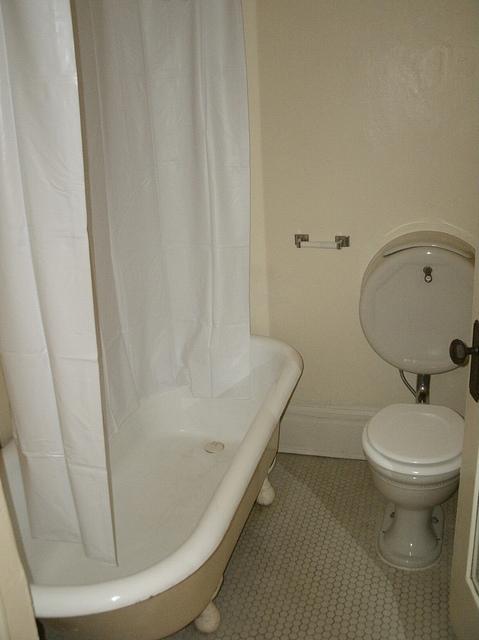Is there a bathtub in this bathroom?
Quick response, please. Yes. What is on the side of the tub?
Give a very brief answer. Toilet. Is the bathroom clean?
Quick response, please. Yes. Where is the bathroom floor?
Give a very brief answer. Bottom. Is the shower curtain on the outside of the tub?
Short answer required. No. Is this a walk in shower?
Answer briefly. No. What is laying on the side of the tub?
Quick response, please. Nothing. Is the toilet properly running?
Be succinct. Yes. Is this a modern device?
Keep it brief. No. Do you like the floor tiles of this bathroom?
Keep it brief. No. What is the tub made of?
Short answer required. Porcelain. What is leaning against the bathtub?
Concise answer only. Shower curtain. Is the seat up?
Write a very short answer. No. Does the toilet seat have a cover?
Short answer required. Yes. Is the toilet seat up or down?
Concise answer only. Down. Is there any toilet paper?
Give a very brief answer. No. Is there extra toilet paper?
Quick response, please. No. What is in the bath water?
Write a very short answer. Nothing. 